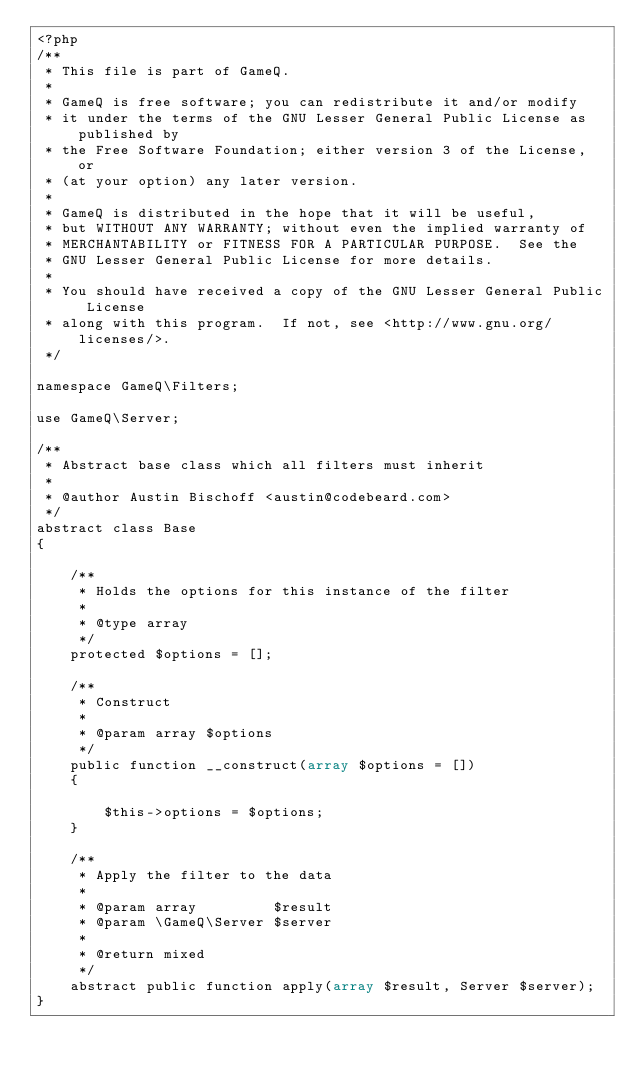Convert code to text. <code><loc_0><loc_0><loc_500><loc_500><_PHP_><?php
/**
 * This file is part of GameQ.
 *
 * GameQ is free software; you can redistribute it and/or modify
 * it under the terms of the GNU Lesser General Public License as published by
 * the Free Software Foundation; either version 3 of the License, or
 * (at your option) any later version.
 *
 * GameQ is distributed in the hope that it will be useful,
 * but WITHOUT ANY WARRANTY; without even the implied warranty of
 * MERCHANTABILITY or FITNESS FOR A PARTICULAR PURPOSE.  See the
 * GNU Lesser General Public License for more details.
 *
 * You should have received a copy of the GNU Lesser General Public License
 * along with this program.  If not, see <http://www.gnu.org/licenses/>.
 */

namespace GameQ\Filters;

use GameQ\Server;

/**
 * Abstract base class which all filters must inherit
 *
 * @author Austin Bischoff <austin@codebeard.com>
 */
abstract class Base
{

    /**
     * Holds the options for this instance of the filter
     *
     * @type array
     */
    protected $options = [];

    /**
     * Construct
     *
     * @param array $options
     */
    public function __construct(array $options = [])
    {

        $this->options = $options;
    }

    /**
     * Apply the filter to the data
     *
     * @param array         $result
     * @param \GameQ\Server $server
     *
     * @return mixed
     */
    abstract public function apply(array $result, Server $server);
}
</code> 